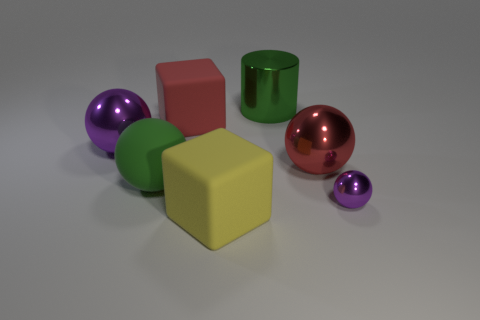There is a large purple shiny thing; does it have the same shape as the big green thing left of the yellow rubber block?
Provide a succinct answer. Yes. There is a yellow rubber thing; how many large metal spheres are on the left side of it?
Your response must be concise. 1. Do the purple thing behind the small object and the small purple thing have the same shape?
Offer a very short reply. Yes. There is a object in front of the tiny purple metallic thing; what color is it?
Provide a short and direct response. Yellow. What shape is the red object that is the same material as the big yellow object?
Your answer should be very brief. Cube. Are there any other things that have the same color as the large rubber sphere?
Offer a terse response. Yes. Is the number of shiny objects left of the large red sphere greater than the number of big green objects behind the red rubber thing?
Offer a very short reply. Yes. What number of other red spheres have the same size as the red shiny ball?
Your answer should be compact. 0. Are there fewer purple metal things that are right of the red metallic ball than small metal spheres that are in front of the small purple metallic object?
Make the answer very short. No. Is there a yellow rubber object of the same shape as the small metal object?
Your answer should be very brief. No. 